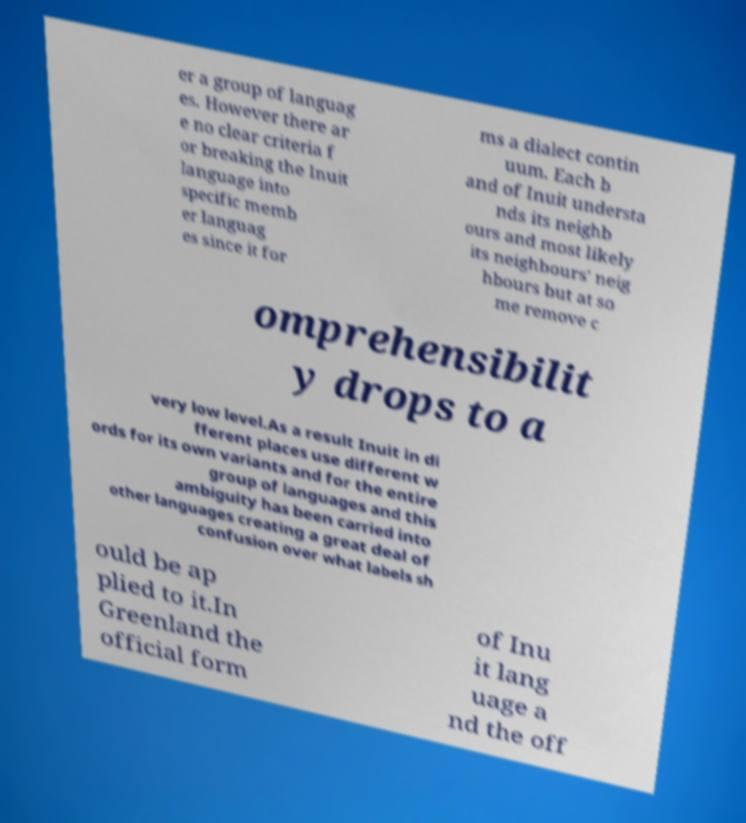Could you extract and type out the text from this image? er a group of languag es. However there ar e no clear criteria f or breaking the Inuit language into specific memb er languag es since it for ms a dialect contin uum. Each b and of Inuit understa nds its neighb ours and most likely its neighbours' neig hbours but at so me remove c omprehensibilit y drops to a very low level.As a result Inuit in di fferent places use different w ords for its own variants and for the entire group of languages and this ambiguity has been carried into other languages creating a great deal of confusion over what labels sh ould be ap plied to it.In Greenland the official form of Inu it lang uage a nd the off 